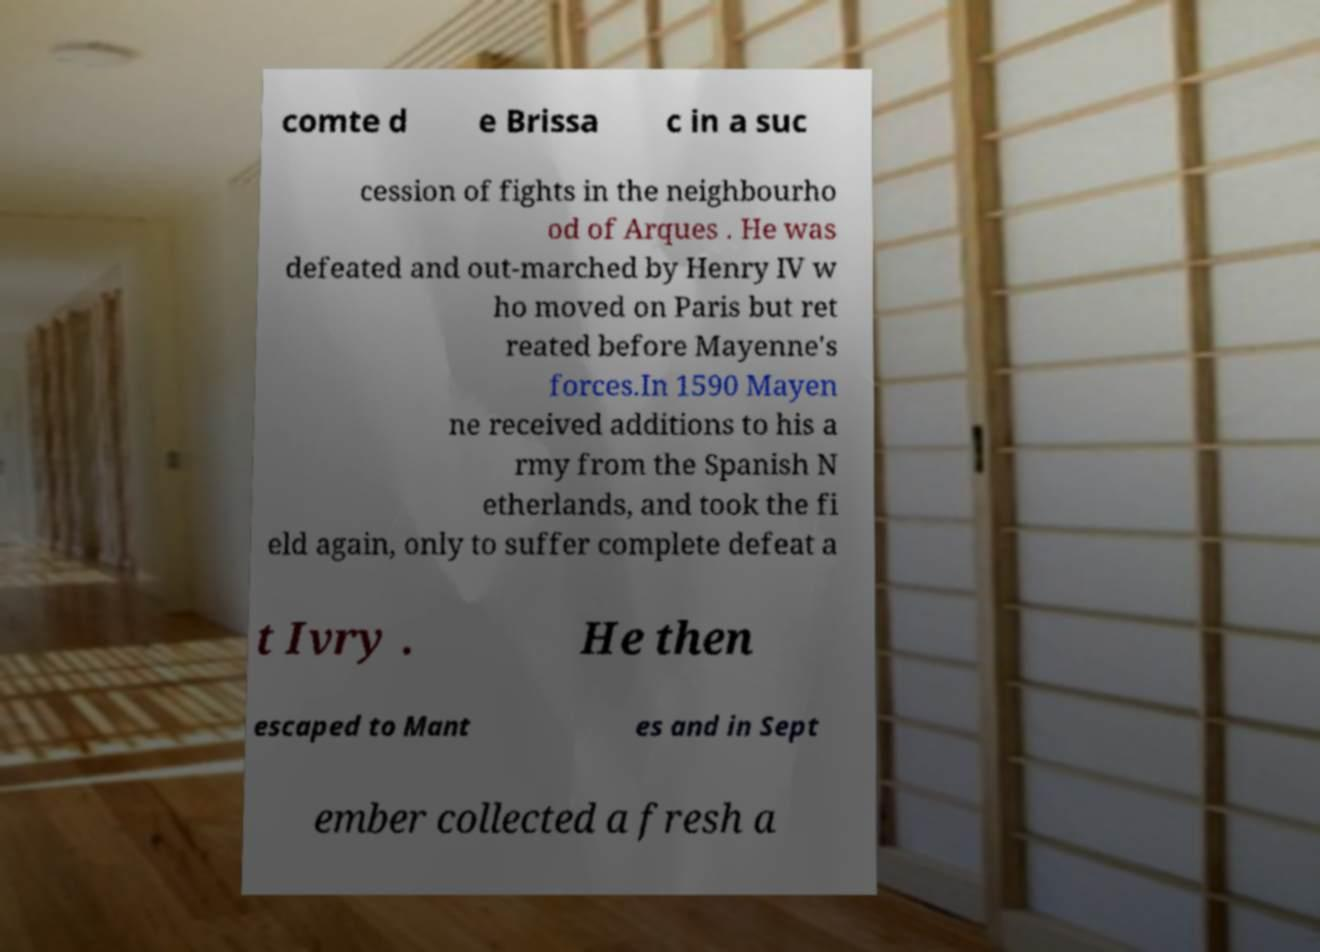What messages or text are displayed in this image? I need them in a readable, typed format. comte d e Brissa c in a suc cession of fights in the neighbourho od of Arques . He was defeated and out-marched by Henry IV w ho moved on Paris but ret reated before Mayenne's forces.In 1590 Mayen ne received additions to his a rmy from the Spanish N etherlands, and took the fi eld again, only to suffer complete defeat a t Ivry . He then escaped to Mant es and in Sept ember collected a fresh a 